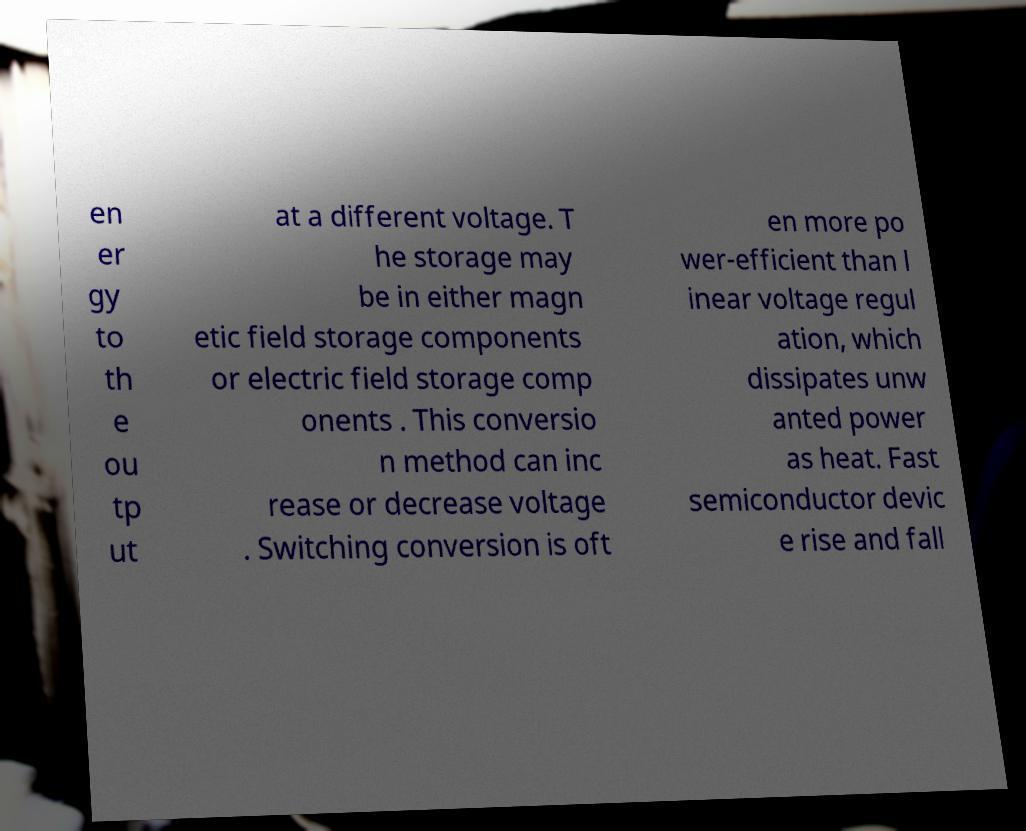Please identify and transcribe the text found in this image. en er gy to th e ou tp ut at a different voltage. T he storage may be in either magn etic field storage components or electric field storage comp onents . This conversio n method can inc rease or decrease voltage . Switching conversion is oft en more po wer-efficient than l inear voltage regul ation, which dissipates unw anted power as heat. Fast semiconductor devic e rise and fall 